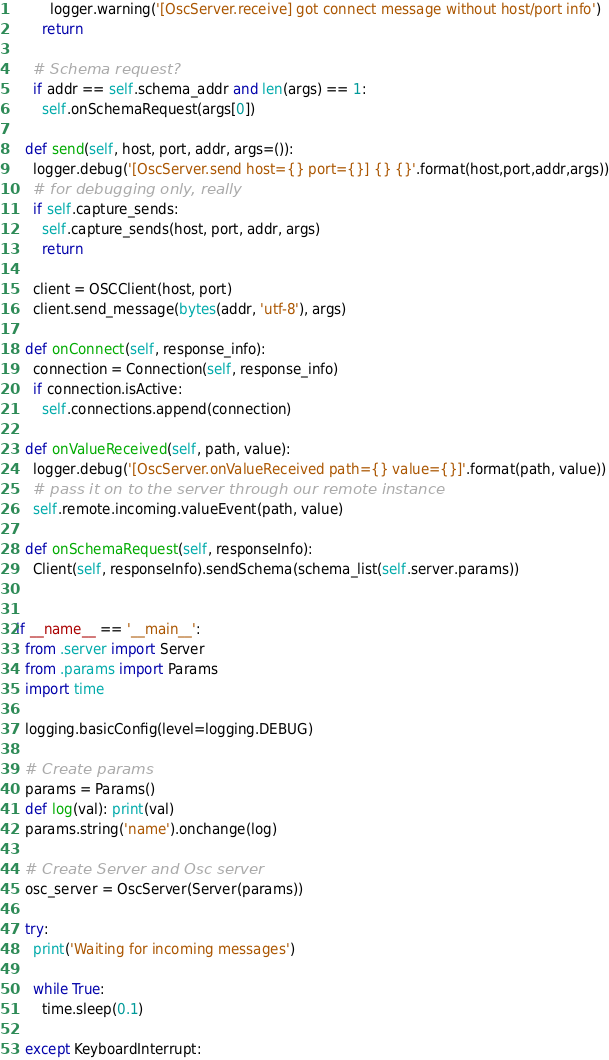<code> <loc_0><loc_0><loc_500><loc_500><_Python_>        logger.warning('[OscServer.receive] got connect message without host/port info')
      return

    # Schema request?
    if addr == self.schema_addr and len(args) == 1:
      self.onSchemaRequest(args[0])

  def send(self, host, port, addr, args=()):
    logger.debug('[OscServer.send host={} port={}] {} {}'.format(host,port,addr,args))
    # for debugging only, really
    if self.capture_sends:
      self.capture_sends(host, port, addr, args)
      return

    client = OSCClient(host, port)
    client.send_message(bytes(addr, 'utf-8'), args)

  def onConnect(self, response_info):
    connection = Connection(self, response_info)
    if connection.isActive:
      self.connections.append(connection)

  def onValueReceived(self, path, value):
    logger.debug('[OscServer.onValueReceived path={} value={}]'.format(path, value))
    # pass it on to the server through our remote instance
    self.remote.incoming.valueEvent(path, value)
  
  def onSchemaRequest(self, responseInfo):
    Client(self, responseInfo).sendSchema(schema_list(self.server.params))


if __name__ == '__main__':
  from .server import Server
  from .params import Params
  import time

  logging.basicConfig(level=logging.DEBUG)

  # Create params
  params = Params()
  def log(val): print(val)
  params.string('name').onchange(log)

  # Create Server and Osc server
  osc_server = OscServer(Server(params))

  try:
    print('Waiting for incoming messages')

    while True:
      time.sleep(0.1)

  except KeyboardInterrupt:</code> 